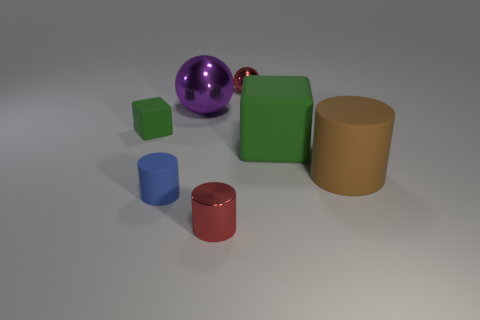Add 2 large purple shiny spheres. How many objects exist? 9 Subtract all cubes. How many objects are left? 5 Subtract all yellow cylinders. Subtract all gray balls. How many cylinders are left? 3 Subtract all purple metal cubes. Subtract all blue matte cylinders. How many objects are left? 6 Add 5 rubber cylinders. How many rubber cylinders are left? 7 Add 6 large purple metallic things. How many large purple metallic things exist? 7 Subtract 1 red spheres. How many objects are left? 6 